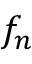<formula> <loc_0><loc_0><loc_500><loc_500>f _ { n }</formula> 